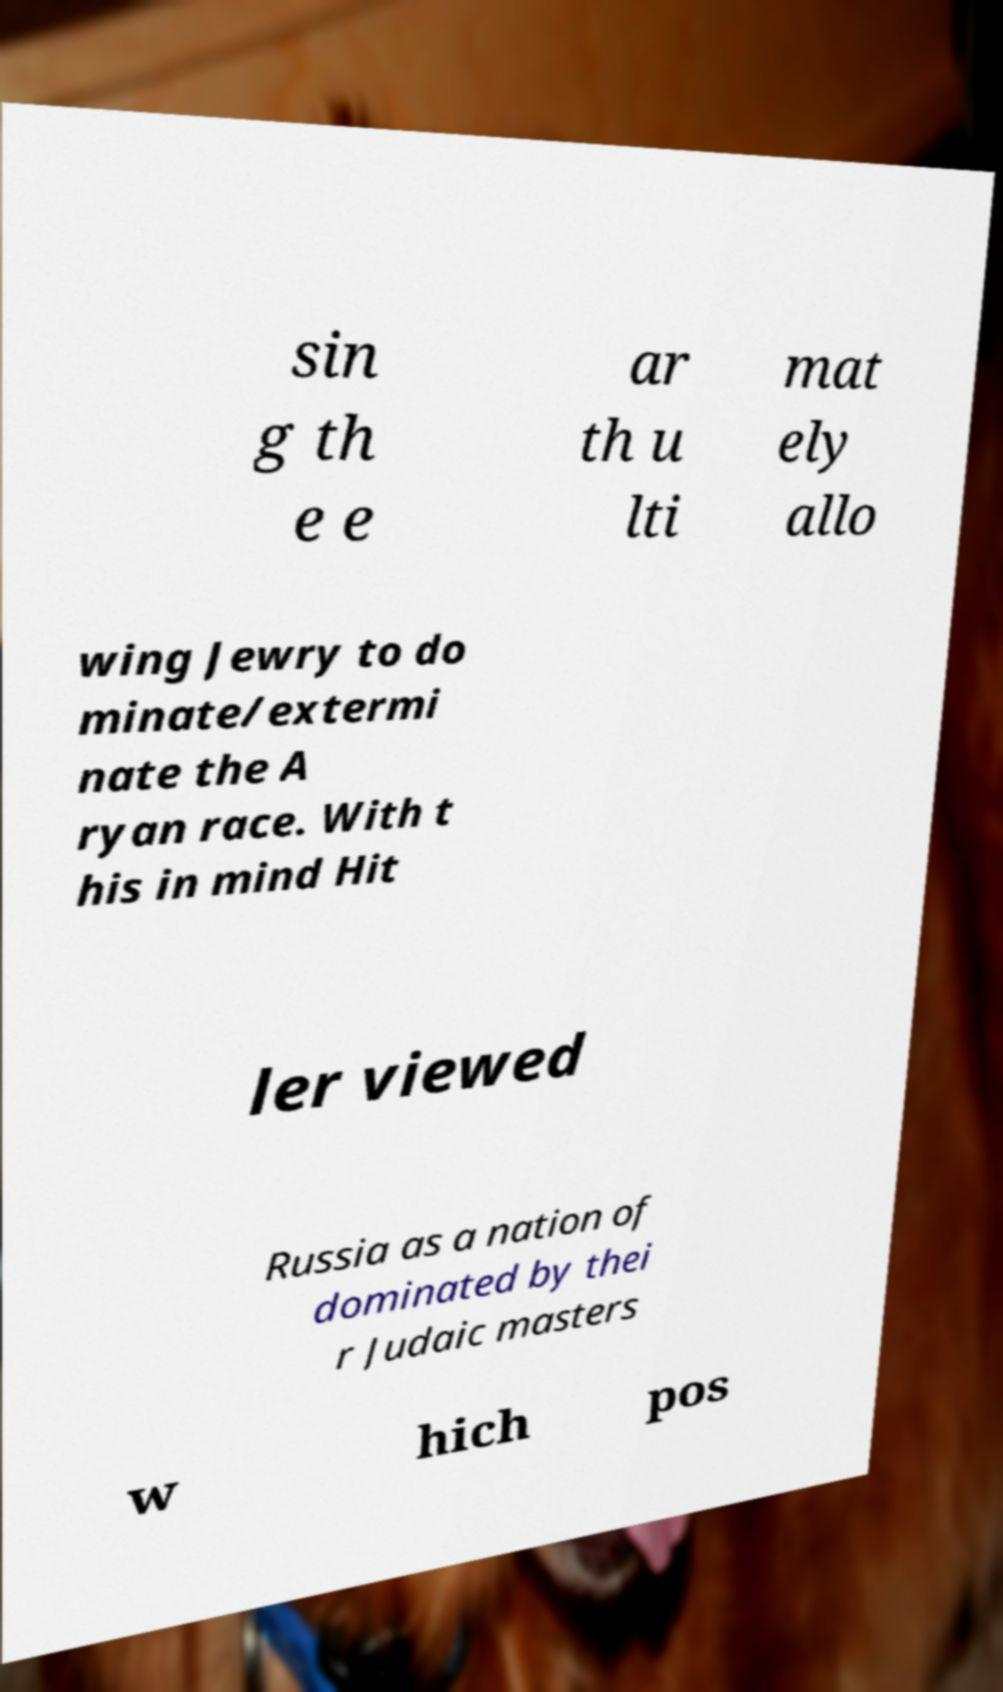Could you assist in decoding the text presented in this image and type it out clearly? sin g th e e ar th u lti mat ely allo wing Jewry to do minate/extermi nate the A ryan race. With t his in mind Hit ler viewed Russia as a nation of dominated by thei r Judaic masters w hich pos 